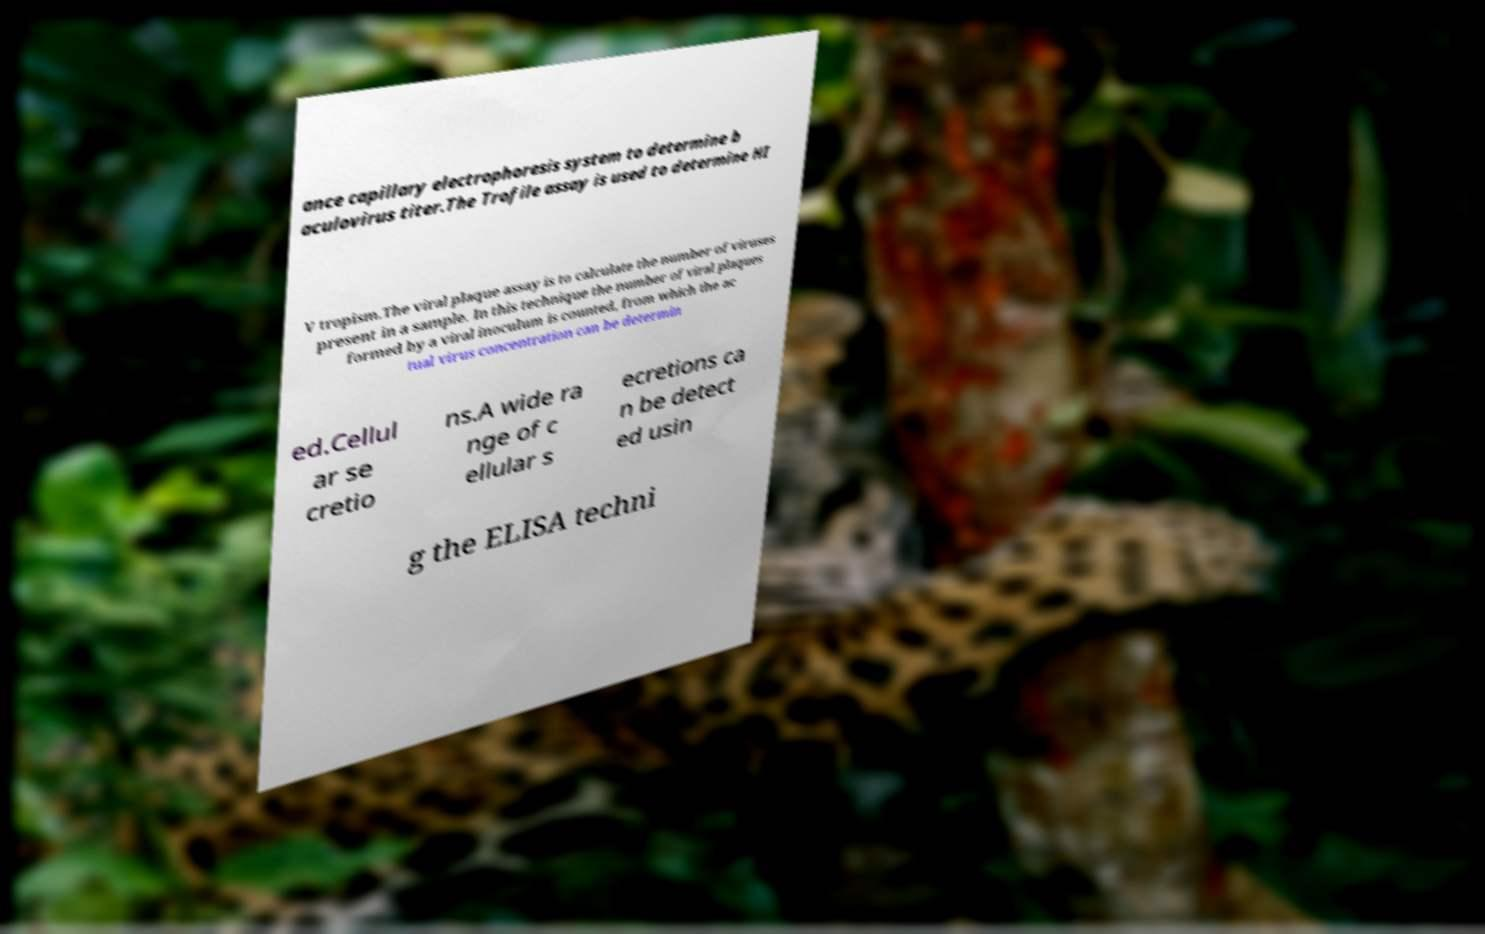For documentation purposes, I need the text within this image transcribed. Could you provide that? ance capillary electrophoresis system to determine b aculovirus titer.The Trofile assay is used to determine HI V tropism.The viral plaque assay is to calculate the number of viruses present in a sample. In this technique the number of viral plaques formed by a viral inoculum is counted, from which the ac tual virus concentration can be determin ed.Cellul ar se cretio ns.A wide ra nge of c ellular s ecretions ca n be detect ed usin g the ELISA techni 